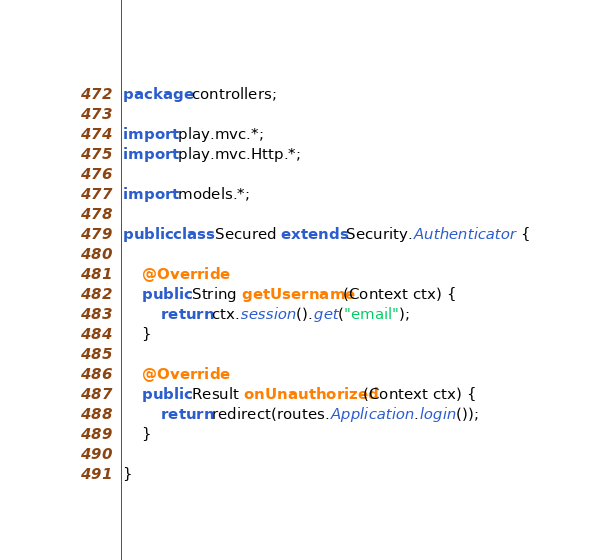Convert code to text. <code><loc_0><loc_0><loc_500><loc_500><_Java_>package controllers;

import play.mvc.*;
import play.mvc.Http.*;

import models.*;

public class Secured extends Security.Authenticator {
    
    @Override
    public String getUsername(Context ctx) {
        return ctx.session().get("email");
    }
    
    @Override
    public Result onUnauthorized(Context ctx) {
        return redirect(routes.Application.login());
    }
    
}</code> 